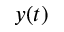Convert formula to latex. <formula><loc_0><loc_0><loc_500><loc_500>y ( t )</formula> 